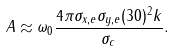<formula> <loc_0><loc_0><loc_500><loc_500>A \approx \omega _ { 0 } \frac { 4 \pi \sigma _ { x , e } \sigma _ { y , e } ( 3 0 ) ^ { 2 } k } { \sigma _ { c } } .</formula> 